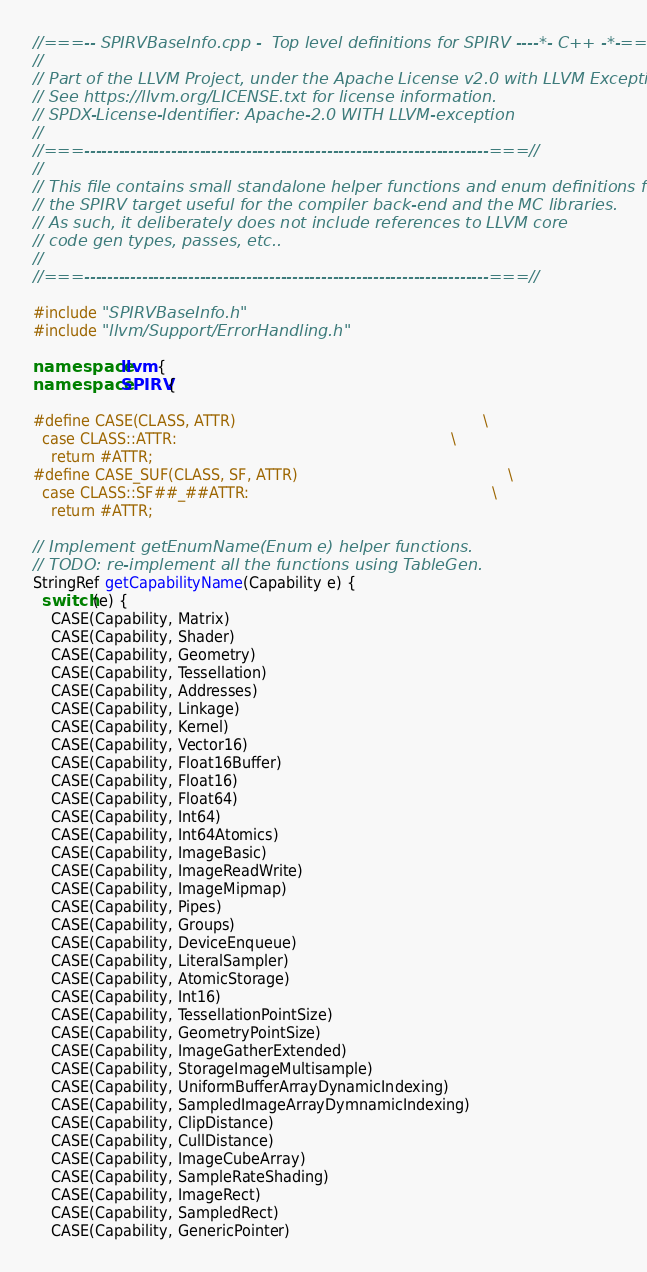<code> <loc_0><loc_0><loc_500><loc_500><_C++_>//===-- SPIRVBaseInfo.cpp -  Top level definitions for SPIRV ----*- C++ -*-===//
//
// Part of the LLVM Project, under the Apache License v2.0 with LLVM Exceptions.
// See https://llvm.org/LICENSE.txt for license information.
// SPDX-License-Identifier: Apache-2.0 WITH LLVM-exception
//
//===----------------------------------------------------------------------===//
//
// This file contains small standalone helper functions and enum definitions for
// the SPIRV target useful for the compiler back-end and the MC libraries.
// As such, it deliberately does not include references to LLVM core
// code gen types, passes, etc..
//
//===----------------------------------------------------------------------===//

#include "SPIRVBaseInfo.h"
#include "llvm/Support/ErrorHandling.h"

namespace llvm {
namespace SPIRV {

#define CASE(CLASS, ATTR)                                                      \
  case CLASS::ATTR:                                                            \
    return #ATTR;
#define CASE_SUF(CLASS, SF, ATTR)                                              \
  case CLASS::SF##_##ATTR:                                                     \
    return #ATTR;

// Implement getEnumName(Enum e) helper functions.
// TODO: re-implement all the functions using TableGen.
StringRef getCapabilityName(Capability e) {
  switch (e) {
    CASE(Capability, Matrix)
    CASE(Capability, Shader)
    CASE(Capability, Geometry)
    CASE(Capability, Tessellation)
    CASE(Capability, Addresses)
    CASE(Capability, Linkage)
    CASE(Capability, Kernel)
    CASE(Capability, Vector16)
    CASE(Capability, Float16Buffer)
    CASE(Capability, Float16)
    CASE(Capability, Float64)
    CASE(Capability, Int64)
    CASE(Capability, Int64Atomics)
    CASE(Capability, ImageBasic)
    CASE(Capability, ImageReadWrite)
    CASE(Capability, ImageMipmap)
    CASE(Capability, Pipes)
    CASE(Capability, Groups)
    CASE(Capability, DeviceEnqueue)
    CASE(Capability, LiteralSampler)
    CASE(Capability, AtomicStorage)
    CASE(Capability, Int16)
    CASE(Capability, TessellationPointSize)
    CASE(Capability, GeometryPointSize)
    CASE(Capability, ImageGatherExtended)
    CASE(Capability, StorageImageMultisample)
    CASE(Capability, UniformBufferArrayDynamicIndexing)
    CASE(Capability, SampledImageArrayDymnamicIndexing)
    CASE(Capability, ClipDistance)
    CASE(Capability, CullDistance)
    CASE(Capability, ImageCubeArray)
    CASE(Capability, SampleRateShading)
    CASE(Capability, ImageRect)
    CASE(Capability, SampledRect)
    CASE(Capability, GenericPointer)</code> 